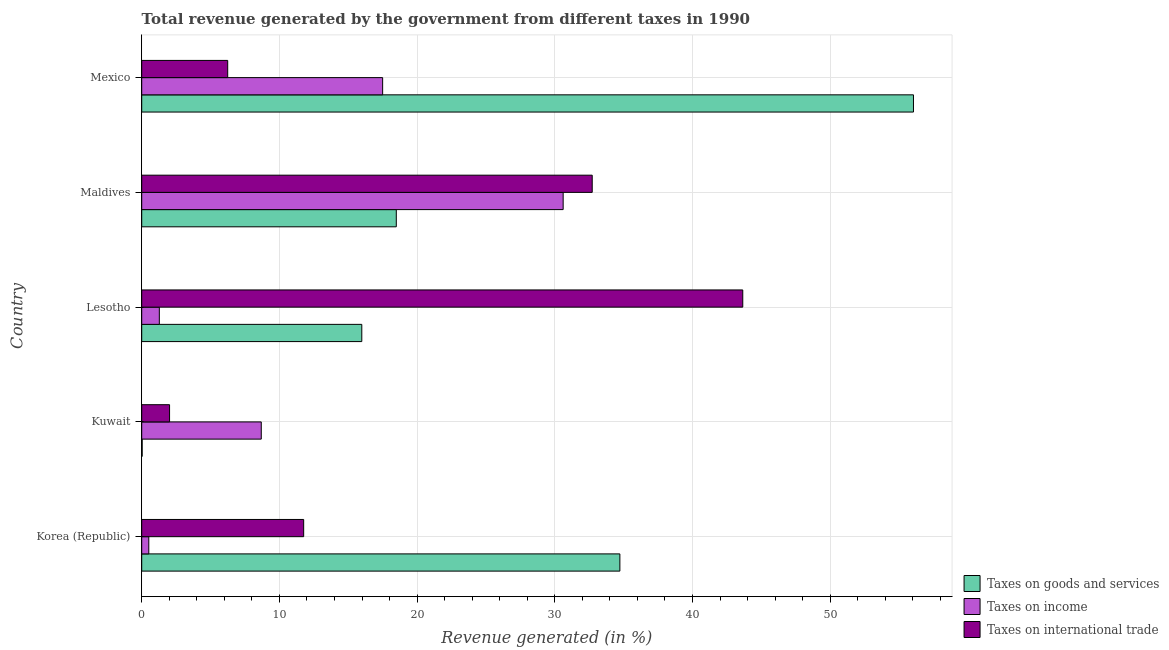Are the number of bars per tick equal to the number of legend labels?
Your response must be concise. Yes. Are the number of bars on each tick of the Y-axis equal?
Provide a short and direct response. Yes. What is the label of the 1st group of bars from the top?
Offer a terse response. Mexico. What is the percentage of revenue generated by tax on international trade in Lesotho?
Provide a short and direct response. 43.65. Across all countries, what is the maximum percentage of revenue generated by taxes on income?
Keep it short and to the point. 30.61. Across all countries, what is the minimum percentage of revenue generated by taxes on income?
Make the answer very short. 0.51. In which country was the percentage of revenue generated by taxes on goods and services maximum?
Make the answer very short. Mexico. In which country was the percentage of revenue generated by tax on international trade minimum?
Provide a short and direct response. Kuwait. What is the total percentage of revenue generated by tax on international trade in the graph?
Offer a terse response. 96.39. What is the difference between the percentage of revenue generated by tax on international trade in Maldives and that in Mexico?
Your answer should be very brief. 26.47. What is the difference between the percentage of revenue generated by taxes on goods and services in Kuwait and the percentage of revenue generated by taxes on income in Mexico?
Provide a short and direct response. -17.46. What is the average percentage of revenue generated by taxes on goods and services per country?
Offer a terse response. 25.05. What is the difference between the percentage of revenue generated by taxes on income and percentage of revenue generated by taxes on goods and services in Korea (Republic)?
Your answer should be compact. -34.21. In how many countries, is the percentage of revenue generated by taxes on income greater than 36 %?
Make the answer very short. 0. What is the ratio of the percentage of revenue generated by taxes on goods and services in Lesotho to that in Maldives?
Keep it short and to the point. 0.86. What is the difference between the highest and the second highest percentage of revenue generated by taxes on goods and services?
Your answer should be very brief. 21.32. What is the difference between the highest and the lowest percentage of revenue generated by taxes on goods and services?
Keep it short and to the point. 56.01. Is the sum of the percentage of revenue generated by taxes on goods and services in Kuwait and Maldives greater than the maximum percentage of revenue generated by taxes on income across all countries?
Make the answer very short. No. What does the 3rd bar from the top in Lesotho represents?
Offer a very short reply. Taxes on goods and services. What does the 2nd bar from the bottom in Korea (Republic) represents?
Keep it short and to the point. Taxes on income. How many bars are there?
Provide a short and direct response. 15. Are all the bars in the graph horizontal?
Make the answer very short. Yes. How many countries are there in the graph?
Keep it short and to the point. 5. What is the difference between two consecutive major ticks on the X-axis?
Ensure brevity in your answer.  10. Are the values on the major ticks of X-axis written in scientific E-notation?
Offer a very short reply. No. Does the graph contain any zero values?
Your response must be concise. No. Where does the legend appear in the graph?
Offer a very short reply. Bottom right. How many legend labels are there?
Offer a very short reply. 3. How are the legend labels stacked?
Your answer should be very brief. Vertical. What is the title of the graph?
Ensure brevity in your answer.  Total revenue generated by the government from different taxes in 1990. Does "Ages 20-50" appear as one of the legend labels in the graph?
Keep it short and to the point. No. What is the label or title of the X-axis?
Keep it short and to the point. Revenue generated (in %). What is the Revenue generated (in %) of Taxes on goods and services in Korea (Republic)?
Your answer should be very brief. 34.72. What is the Revenue generated (in %) of Taxes on income in Korea (Republic)?
Make the answer very short. 0.51. What is the Revenue generated (in %) of Taxes on international trade in Korea (Republic)?
Your response must be concise. 11.76. What is the Revenue generated (in %) in Taxes on goods and services in Kuwait?
Give a very brief answer. 0.03. What is the Revenue generated (in %) in Taxes on income in Kuwait?
Provide a succinct answer. 8.68. What is the Revenue generated (in %) of Taxes on international trade in Kuwait?
Offer a terse response. 2.02. What is the Revenue generated (in %) in Taxes on goods and services in Lesotho?
Ensure brevity in your answer.  15.98. What is the Revenue generated (in %) in Taxes on income in Lesotho?
Make the answer very short. 1.28. What is the Revenue generated (in %) in Taxes on international trade in Lesotho?
Your answer should be compact. 43.65. What is the Revenue generated (in %) of Taxes on goods and services in Maldives?
Offer a very short reply. 18.49. What is the Revenue generated (in %) in Taxes on income in Maldives?
Make the answer very short. 30.61. What is the Revenue generated (in %) in Taxes on international trade in Maldives?
Give a very brief answer. 32.72. What is the Revenue generated (in %) of Taxes on goods and services in Mexico?
Your answer should be compact. 56.05. What is the Revenue generated (in %) of Taxes on income in Mexico?
Ensure brevity in your answer.  17.5. What is the Revenue generated (in %) of Taxes on international trade in Mexico?
Your response must be concise. 6.24. Across all countries, what is the maximum Revenue generated (in %) in Taxes on goods and services?
Make the answer very short. 56.05. Across all countries, what is the maximum Revenue generated (in %) in Taxes on income?
Ensure brevity in your answer.  30.61. Across all countries, what is the maximum Revenue generated (in %) of Taxes on international trade?
Give a very brief answer. 43.65. Across all countries, what is the minimum Revenue generated (in %) in Taxes on goods and services?
Your answer should be very brief. 0.03. Across all countries, what is the minimum Revenue generated (in %) of Taxes on income?
Offer a very short reply. 0.51. Across all countries, what is the minimum Revenue generated (in %) of Taxes on international trade?
Give a very brief answer. 2.02. What is the total Revenue generated (in %) in Taxes on goods and services in the graph?
Make the answer very short. 125.27. What is the total Revenue generated (in %) in Taxes on income in the graph?
Give a very brief answer. 58.57. What is the total Revenue generated (in %) of Taxes on international trade in the graph?
Your answer should be compact. 96.39. What is the difference between the Revenue generated (in %) in Taxes on goods and services in Korea (Republic) and that in Kuwait?
Provide a succinct answer. 34.69. What is the difference between the Revenue generated (in %) in Taxes on income in Korea (Republic) and that in Kuwait?
Your answer should be compact. -8.17. What is the difference between the Revenue generated (in %) of Taxes on international trade in Korea (Republic) and that in Kuwait?
Provide a succinct answer. 9.74. What is the difference between the Revenue generated (in %) of Taxes on goods and services in Korea (Republic) and that in Lesotho?
Your response must be concise. 18.74. What is the difference between the Revenue generated (in %) in Taxes on income in Korea (Republic) and that in Lesotho?
Your response must be concise. -0.76. What is the difference between the Revenue generated (in %) in Taxes on international trade in Korea (Republic) and that in Lesotho?
Ensure brevity in your answer.  -31.89. What is the difference between the Revenue generated (in %) in Taxes on goods and services in Korea (Republic) and that in Maldives?
Give a very brief answer. 16.24. What is the difference between the Revenue generated (in %) in Taxes on income in Korea (Republic) and that in Maldives?
Keep it short and to the point. -30.09. What is the difference between the Revenue generated (in %) in Taxes on international trade in Korea (Republic) and that in Maldives?
Offer a terse response. -20.95. What is the difference between the Revenue generated (in %) in Taxes on goods and services in Korea (Republic) and that in Mexico?
Provide a short and direct response. -21.32. What is the difference between the Revenue generated (in %) in Taxes on income in Korea (Republic) and that in Mexico?
Ensure brevity in your answer.  -16.98. What is the difference between the Revenue generated (in %) of Taxes on international trade in Korea (Republic) and that in Mexico?
Keep it short and to the point. 5.52. What is the difference between the Revenue generated (in %) in Taxes on goods and services in Kuwait and that in Lesotho?
Offer a very short reply. -15.95. What is the difference between the Revenue generated (in %) in Taxes on income in Kuwait and that in Lesotho?
Your answer should be compact. 7.4. What is the difference between the Revenue generated (in %) of Taxes on international trade in Kuwait and that in Lesotho?
Make the answer very short. -41.63. What is the difference between the Revenue generated (in %) in Taxes on goods and services in Kuwait and that in Maldives?
Give a very brief answer. -18.46. What is the difference between the Revenue generated (in %) of Taxes on income in Kuwait and that in Maldives?
Make the answer very short. -21.92. What is the difference between the Revenue generated (in %) in Taxes on international trade in Kuwait and that in Maldives?
Offer a terse response. -30.69. What is the difference between the Revenue generated (in %) of Taxes on goods and services in Kuwait and that in Mexico?
Your response must be concise. -56.01. What is the difference between the Revenue generated (in %) in Taxes on income in Kuwait and that in Mexico?
Keep it short and to the point. -8.81. What is the difference between the Revenue generated (in %) of Taxes on international trade in Kuwait and that in Mexico?
Your answer should be very brief. -4.22. What is the difference between the Revenue generated (in %) of Taxes on goods and services in Lesotho and that in Maldives?
Provide a short and direct response. -2.51. What is the difference between the Revenue generated (in %) in Taxes on income in Lesotho and that in Maldives?
Your response must be concise. -29.33. What is the difference between the Revenue generated (in %) of Taxes on international trade in Lesotho and that in Maldives?
Your response must be concise. 10.93. What is the difference between the Revenue generated (in %) in Taxes on goods and services in Lesotho and that in Mexico?
Provide a succinct answer. -40.06. What is the difference between the Revenue generated (in %) in Taxes on income in Lesotho and that in Mexico?
Keep it short and to the point. -16.22. What is the difference between the Revenue generated (in %) of Taxes on international trade in Lesotho and that in Mexico?
Give a very brief answer. 37.4. What is the difference between the Revenue generated (in %) of Taxes on goods and services in Maldives and that in Mexico?
Offer a terse response. -37.56. What is the difference between the Revenue generated (in %) in Taxes on income in Maldives and that in Mexico?
Make the answer very short. 13.11. What is the difference between the Revenue generated (in %) of Taxes on international trade in Maldives and that in Mexico?
Ensure brevity in your answer.  26.47. What is the difference between the Revenue generated (in %) of Taxes on goods and services in Korea (Republic) and the Revenue generated (in %) of Taxes on income in Kuwait?
Offer a very short reply. 26.04. What is the difference between the Revenue generated (in %) of Taxes on goods and services in Korea (Republic) and the Revenue generated (in %) of Taxes on international trade in Kuwait?
Provide a succinct answer. 32.7. What is the difference between the Revenue generated (in %) in Taxes on income in Korea (Republic) and the Revenue generated (in %) in Taxes on international trade in Kuwait?
Ensure brevity in your answer.  -1.51. What is the difference between the Revenue generated (in %) in Taxes on goods and services in Korea (Republic) and the Revenue generated (in %) in Taxes on income in Lesotho?
Offer a terse response. 33.45. What is the difference between the Revenue generated (in %) of Taxes on goods and services in Korea (Republic) and the Revenue generated (in %) of Taxes on international trade in Lesotho?
Offer a terse response. -8.92. What is the difference between the Revenue generated (in %) of Taxes on income in Korea (Republic) and the Revenue generated (in %) of Taxes on international trade in Lesotho?
Offer a very short reply. -43.14. What is the difference between the Revenue generated (in %) of Taxes on goods and services in Korea (Republic) and the Revenue generated (in %) of Taxes on income in Maldives?
Provide a short and direct response. 4.12. What is the difference between the Revenue generated (in %) in Taxes on goods and services in Korea (Republic) and the Revenue generated (in %) in Taxes on international trade in Maldives?
Provide a succinct answer. 2.01. What is the difference between the Revenue generated (in %) of Taxes on income in Korea (Republic) and the Revenue generated (in %) of Taxes on international trade in Maldives?
Give a very brief answer. -32.2. What is the difference between the Revenue generated (in %) in Taxes on goods and services in Korea (Republic) and the Revenue generated (in %) in Taxes on income in Mexico?
Give a very brief answer. 17.23. What is the difference between the Revenue generated (in %) of Taxes on goods and services in Korea (Republic) and the Revenue generated (in %) of Taxes on international trade in Mexico?
Your answer should be compact. 28.48. What is the difference between the Revenue generated (in %) in Taxes on income in Korea (Republic) and the Revenue generated (in %) in Taxes on international trade in Mexico?
Your response must be concise. -5.73. What is the difference between the Revenue generated (in %) in Taxes on goods and services in Kuwait and the Revenue generated (in %) in Taxes on income in Lesotho?
Offer a very short reply. -1.25. What is the difference between the Revenue generated (in %) in Taxes on goods and services in Kuwait and the Revenue generated (in %) in Taxes on international trade in Lesotho?
Provide a short and direct response. -43.62. What is the difference between the Revenue generated (in %) of Taxes on income in Kuwait and the Revenue generated (in %) of Taxes on international trade in Lesotho?
Your answer should be compact. -34.97. What is the difference between the Revenue generated (in %) in Taxes on goods and services in Kuwait and the Revenue generated (in %) in Taxes on income in Maldives?
Offer a very short reply. -30.57. What is the difference between the Revenue generated (in %) in Taxes on goods and services in Kuwait and the Revenue generated (in %) in Taxes on international trade in Maldives?
Offer a very short reply. -32.68. What is the difference between the Revenue generated (in %) in Taxes on income in Kuwait and the Revenue generated (in %) in Taxes on international trade in Maldives?
Your response must be concise. -24.03. What is the difference between the Revenue generated (in %) in Taxes on goods and services in Kuwait and the Revenue generated (in %) in Taxes on income in Mexico?
Ensure brevity in your answer.  -17.46. What is the difference between the Revenue generated (in %) of Taxes on goods and services in Kuwait and the Revenue generated (in %) of Taxes on international trade in Mexico?
Offer a terse response. -6.21. What is the difference between the Revenue generated (in %) in Taxes on income in Kuwait and the Revenue generated (in %) in Taxes on international trade in Mexico?
Ensure brevity in your answer.  2.44. What is the difference between the Revenue generated (in %) of Taxes on goods and services in Lesotho and the Revenue generated (in %) of Taxes on income in Maldives?
Your answer should be very brief. -14.62. What is the difference between the Revenue generated (in %) in Taxes on goods and services in Lesotho and the Revenue generated (in %) in Taxes on international trade in Maldives?
Provide a succinct answer. -16.73. What is the difference between the Revenue generated (in %) in Taxes on income in Lesotho and the Revenue generated (in %) in Taxes on international trade in Maldives?
Your answer should be compact. -31.44. What is the difference between the Revenue generated (in %) in Taxes on goods and services in Lesotho and the Revenue generated (in %) in Taxes on income in Mexico?
Provide a short and direct response. -1.51. What is the difference between the Revenue generated (in %) in Taxes on goods and services in Lesotho and the Revenue generated (in %) in Taxes on international trade in Mexico?
Your answer should be very brief. 9.74. What is the difference between the Revenue generated (in %) in Taxes on income in Lesotho and the Revenue generated (in %) in Taxes on international trade in Mexico?
Give a very brief answer. -4.97. What is the difference between the Revenue generated (in %) of Taxes on goods and services in Maldives and the Revenue generated (in %) of Taxes on income in Mexico?
Give a very brief answer. 0.99. What is the difference between the Revenue generated (in %) of Taxes on goods and services in Maldives and the Revenue generated (in %) of Taxes on international trade in Mexico?
Ensure brevity in your answer.  12.24. What is the difference between the Revenue generated (in %) in Taxes on income in Maldives and the Revenue generated (in %) in Taxes on international trade in Mexico?
Provide a short and direct response. 24.36. What is the average Revenue generated (in %) in Taxes on goods and services per country?
Make the answer very short. 25.05. What is the average Revenue generated (in %) in Taxes on income per country?
Provide a succinct answer. 11.71. What is the average Revenue generated (in %) in Taxes on international trade per country?
Offer a very short reply. 19.28. What is the difference between the Revenue generated (in %) in Taxes on goods and services and Revenue generated (in %) in Taxes on income in Korea (Republic)?
Make the answer very short. 34.21. What is the difference between the Revenue generated (in %) in Taxes on goods and services and Revenue generated (in %) in Taxes on international trade in Korea (Republic)?
Ensure brevity in your answer.  22.96. What is the difference between the Revenue generated (in %) in Taxes on income and Revenue generated (in %) in Taxes on international trade in Korea (Republic)?
Offer a terse response. -11.25. What is the difference between the Revenue generated (in %) in Taxes on goods and services and Revenue generated (in %) in Taxes on income in Kuwait?
Ensure brevity in your answer.  -8.65. What is the difference between the Revenue generated (in %) of Taxes on goods and services and Revenue generated (in %) of Taxes on international trade in Kuwait?
Provide a succinct answer. -1.99. What is the difference between the Revenue generated (in %) in Taxes on income and Revenue generated (in %) in Taxes on international trade in Kuwait?
Your answer should be compact. 6.66. What is the difference between the Revenue generated (in %) of Taxes on goods and services and Revenue generated (in %) of Taxes on income in Lesotho?
Offer a terse response. 14.7. What is the difference between the Revenue generated (in %) of Taxes on goods and services and Revenue generated (in %) of Taxes on international trade in Lesotho?
Provide a short and direct response. -27.67. What is the difference between the Revenue generated (in %) in Taxes on income and Revenue generated (in %) in Taxes on international trade in Lesotho?
Ensure brevity in your answer.  -42.37. What is the difference between the Revenue generated (in %) in Taxes on goods and services and Revenue generated (in %) in Taxes on income in Maldives?
Keep it short and to the point. -12.12. What is the difference between the Revenue generated (in %) of Taxes on goods and services and Revenue generated (in %) of Taxes on international trade in Maldives?
Your answer should be compact. -14.23. What is the difference between the Revenue generated (in %) in Taxes on income and Revenue generated (in %) in Taxes on international trade in Maldives?
Make the answer very short. -2.11. What is the difference between the Revenue generated (in %) of Taxes on goods and services and Revenue generated (in %) of Taxes on income in Mexico?
Give a very brief answer. 38.55. What is the difference between the Revenue generated (in %) of Taxes on goods and services and Revenue generated (in %) of Taxes on international trade in Mexico?
Make the answer very short. 49.8. What is the difference between the Revenue generated (in %) in Taxes on income and Revenue generated (in %) in Taxes on international trade in Mexico?
Keep it short and to the point. 11.25. What is the ratio of the Revenue generated (in %) in Taxes on goods and services in Korea (Republic) to that in Kuwait?
Your response must be concise. 1082.03. What is the ratio of the Revenue generated (in %) in Taxes on income in Korea (Republic) to that in Kuwait?
Ensure brevity in your answer.  0.06. What is the ratio of the Revenue generated (in %) in Taxes on international trade in Korea (Republic) to that in Kuwait?
Make the answer very short. 5.82. What is the ratio of the Revenue generated (in %) in Taxes on goods and services in Korea (Republic) to that in Lesotho?
Offer a very short reply. 2.17. What is the ratio of the Revenue generated (in %) in Taxes on income in Korea (Republic) to that in Lesotho?
Ensure brevity in your answer.  0.4. What is the ratio of the Revenue generated (in %) in Taxes on international trade in Korea (Republic) to that in Lesotho?
Offer a terse response. 0.27. What is the ratio of the Revenue generated (in %) of Taxes on goods and services in Korea (Republic) to that in Maldives?
Keep it short and to the point. 1.88. What is the ratio of the Revenue generated (in %) of Taxes on income in Korea (Republic) to that in Maldives?
Provide a succinct answer. 0.02. What is the ratio of the Revenue generated (in %) of Taxes on international trade in Korea (Republic) to that in Maldives?
Ensure brevity in your answer.  0.36. What is the ratio of the Revenue generated (in %) of Taxes on goods and services in Korea (Republic) to that in Mexico?
Make the answer very short. 0.62. What is the ratio of the Revenue generated (in %) in Taxes on income in Korea (Republic) to that in Mexico?
Offer a very short reply. 0.03. What is the ratio of the Revenue generated (in %) in Taxes on international trade in Korea (Republic) to that in Mexico?
Keep it short and to the point. 1.88. What is the ratio of the Revenue generated (in %) of Taxes on goods and services in Kuwait to that in Lesotho?
Keep it short and to the point. 0. What is the ratio of the Revenue generated (in %) in Taxes on income in Kuwait to that in Lesotho?
Your answer should be very brief. 6.79. What is the ratio of the Revenue generated (in %) of Taxes on international trade in Kuwait to that in Lesotho?
Keep it short and to the point. 0.05. What is the ratio of the Revenue generated (in %) of Taxes on goods and services in Kuwait to that in Maldives?
Make the answer very short. 0. What is the ratio of the Revenue generated (in %) of Taxes on income in Kuwait to that in Maldives?
Your answer should be very brief. 0.28. What is the ratio of the Revenue generated (in %) in Taxes on international trade in Kuwait to that in Maldives?
Offer a terse response. 0.06. What is the ratio of the Revenue generated (in %) in Taxes on goods and services in Kuwait to that in Mexico?
Provide a succinct answer. 0. What is the ratio of the Revenue generated (in %) in Taxes on income in Kuwait to that in Mexico?
Provide a short and direct response. 0.5. What is the ratio of the Revenue generated (in %) in Taxes on international trade in Kuwait to that in Mexico?
Offer a terse response. 0.32. What is the ratio of the Revenue generated (in %) in Taxes on goods and services in Lesotho to that in Maldives?
Give a very brief answer. 0.86. What is the ratio of the Revenue generated (in %) in Taxes on income in Lesotho to that in Maldives?
Keep it short and to the point. 0.04. What is the ratio of the Revenue generated (in %) in Taxes on international trade in Lesotho to that in Maldives?
Keep it short and to the point. 1.33. What is the ratio of the Revenue generated (in %) of Taxes on goods and services in Lesotho to that in Mexico?
Offer a terse response. 0.29. What is the ratio of the Revenue generated (in %) in Taxes on income in Lesotho to that in Mexico?
Ensure brevity in your answer.  0.07. What is the ratio of the Revenue generated (in %) in Taxes on international trade in Lesotho to that in Mexico?
Keep it short and to the point. 6.99. What is the ratio of the Revenue generated (in %) in Taxes on goods and services in Maldives to that in Mexico?
Offer a terse response. 0.33. What is the ratio of the Revenue generated (in %) of Taxes on income in Maldives to that in Mexico?
Your answer should be very brief. 1.75. What is the ratio of the Revenue generated (in %) of Taxes on international trade in Maldives to that in Mexico?
Your response must be concise. 5.24. What is the difference between the highest and the second highest Revenue generated (in %) in Taxes on goods and services?
Provide a succinct answer. 21.32. What is the difference between the highest and the second highest Revenue generated (in %) in Taxes on income?
Provide a short and direct response. 13.11. What is the difference between the highest and the second highest Revenue generated (in %) in Taxes on international trade?
Your answer should be compact. 10.93. What is the difference between the highest and the lowest Revenue generated (in %) in Taxes on goods and services?
Make the answer very short. 56.01. What is the difference between the highest and the lowest Revenue generated (in %) of Taxes on income?
Offer a very short reply. 30.09. What is the difference between the highest and the lowest Revenue generated (in %) of Taxes on international trade?
Offer a terse response. 41.63. 